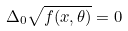Convert formula to latex. <formula><loc_0><loc_0><loc_500><loc_500>\Delta _ { 0 } \sqrt { f ( x , \theta ) } = 0</formula> 